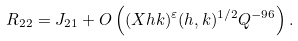Convert formula to latex. <formula><loc_0><loc_0><loc_500><loc_500>R _ { 2 2 } = J _ { 2 1 } + O \left ( ( X h k ) ^ { \varepsilon } ( h , k ) ^ { 1 / 2 } Q ^ { - 9 6 } \right ) .</formula> 